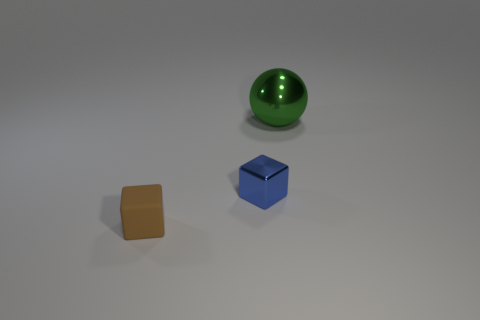How many objects are tiny matte balls or tiny things?
Your answer should be compact. 2. Are there any other things that have the same material as the tiny brown object?
Your response must be concise. No. Is the number of small rubber objects right of the brown matte object less than the number of large green metallic spheres?
Provide a short and direct response. Yes. Is the number of metal blocks that are in front of the big green metal object greater than the number of small rubber things that are to the left of the tiny brown object?
Your response must be concise. Yes. Is there anything else of the same color as the tiny rubber block?
Give a very brief answer. No. There is a thing that is behind the tiny blue shiny cube; what material is it?
Ensure brevity in your answer.  Metal. Is the size of the matte thing the same as the green metallic ball?
Give a very brief answer. No. How many other things are there of the same size as the metallic block?
Ensure brevity in your answer.  1. There is a thing that is on the right side of the metal object that is in front of the thing behind the small shiny block; what shape is it?
Give a very brief answer. Sphere. How many objects are either blocks that are behind the tiny brown thing or blocks right of the small brown rubber thing?
Ensure brevity in your answer.  1. 